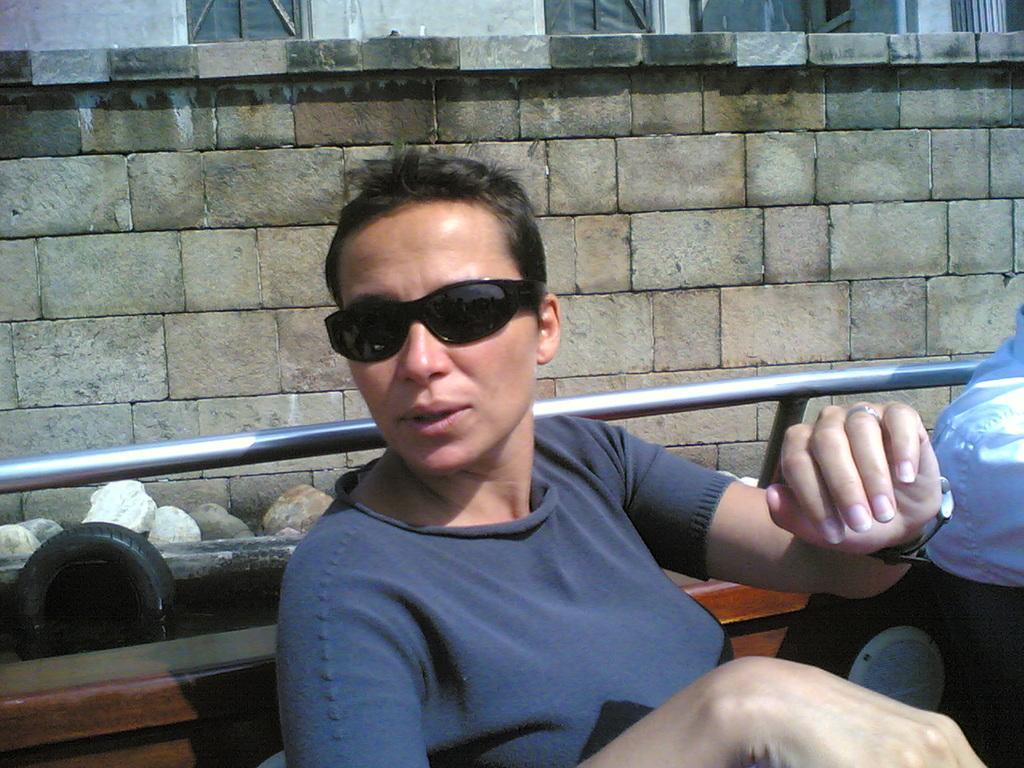How would you summarize this image in a sentence or two? In this image we can see a woman sitting in a boat wearing sunglasses. In the background of the image there is wall. There are stones. There is a tyre in water. 